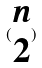Convert formula to latex. <formula><loc_0><loc_0><loc_500><loc_500>( \begin{matrix} n \\ 2 \end{matrix} )</formula> 